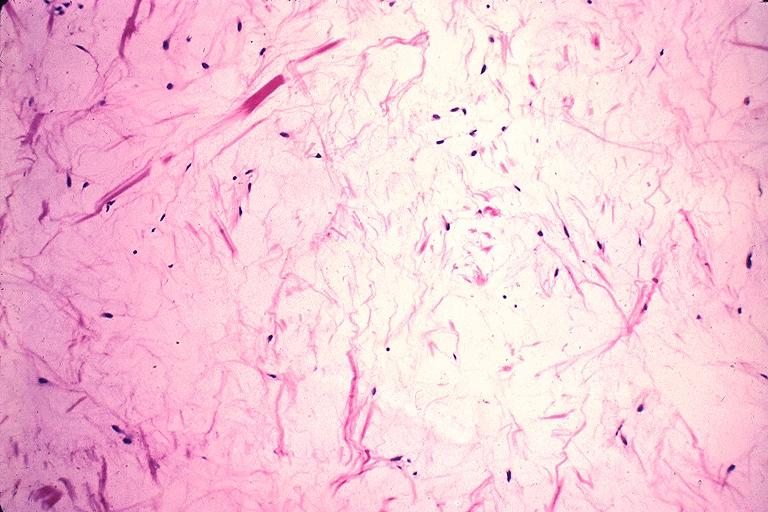what does this image show?
Answer the question using a single word or phrase. Odontogenic myxoma 